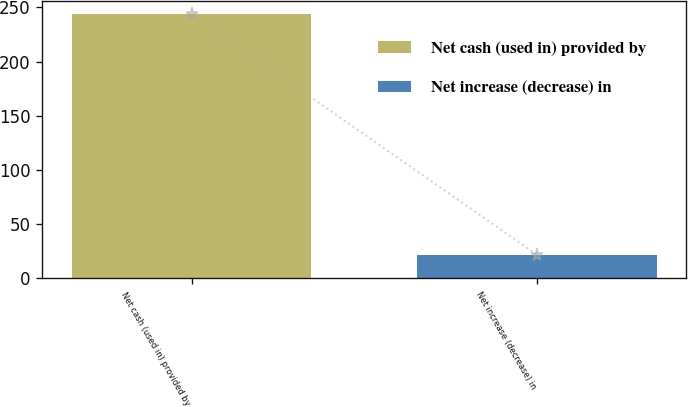<chart> <loc_0><loc_0><loc_500><loc_500><bar_chart><fcel>Net cash (used in) provided by<fcel>Net increase (decrease) in<nl><fcel>243.8<fcel>21.7<nl></chart> 